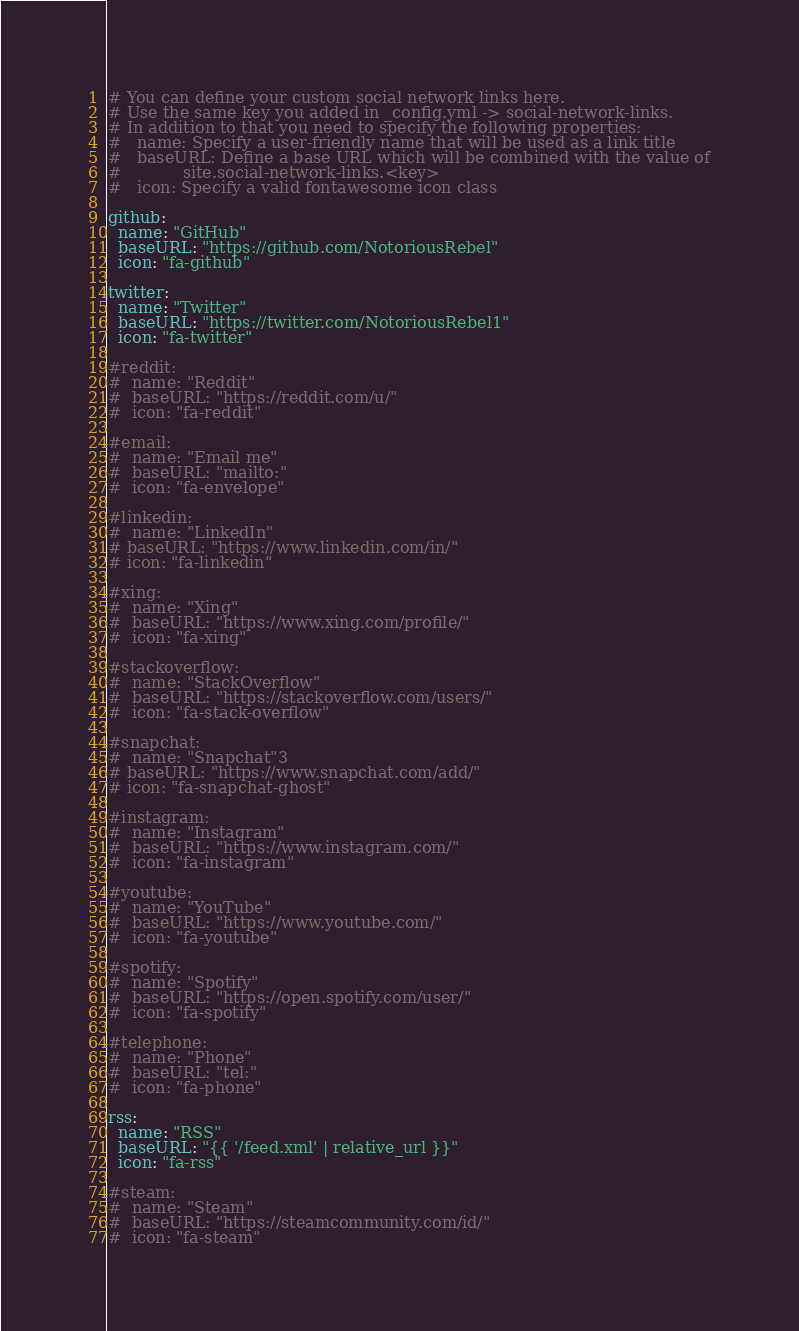<code> <loc_0><loc_0><loc_500><loc_500><_YAML_># You can define your custom social network links here.
# Use the same key you added in _config.yml -> social-network-links.
# In addition to that you need to specify the following properties:
#   name: Specify a user-friendly name that will be used as a link title
#   baseURL: Define a base URL which will be combined with the value of
#            site.social-network-links.<key>
#   icon: Specify a valid fontawesome icon class

github:
  name: "GitHub"
  baseURL: "https://github.com/NotoriousRebel"
  icon: "fa-github"

twitter:
  name: "Twitter"
  baseURL: "https://twitter.com/NotoriousRebel1"
  icon: "fa-twitter"

#reddit:
#  name: "Reddit"
#  baseURL: "https://reddit.com/u/"
#  icon: "fa-reddit"

#email:
#  name: "Email me"
#  baseURL: "mailto:"
#  icon: "fa-envelope"

#linkedin:
#  name: "LinkedIn"
# baseURL: "https://www.linkedin.com/in/"
# icon: "fa-linkedin"

#xing:
#  name: "Xing"
#  baseURL: "https://www.xing.com/profile/"
#  icon: "fa-xing"

#stackoverflow:
#  name: "StackOverflow"
#  baseURL: "https://stackoverflow.com/users/"
#  icon: "fa-stack-overflow"

#snapchat:
#  name: "Snapchat"3
# baseURL: "https://www.snapchat.com/add/"
# icon: "fa-snapchat-ghost"

#instagram:
#  name: "Instagram"
#  baseURL: "https://www.instagram.com/"
#  icon: "fa-instagram"

#youtube:
#  name: "YouTube"
#  baseURL: "https://www.youtube.com/"
#  icon: "fa-youtube"

#spotify:
#  name: "Spotify"
#  baseURL: "https://open.spotify.com/user/"
#  icon: "fa-spotify"

#telephone:
#  name: "Phone"
#  baseURL: "tel:"
#  icon: "fa-phone"

rss:
  name: "RSS"
  baseURL: "{{ '/feed.xml' | relative_url }}"
  icon: "fa-rss"

#steam:
#  name: "Steam"
#  baseURL: "https://steamcommunity.com/id/"
#  icon: "fa-steam"



</code> 